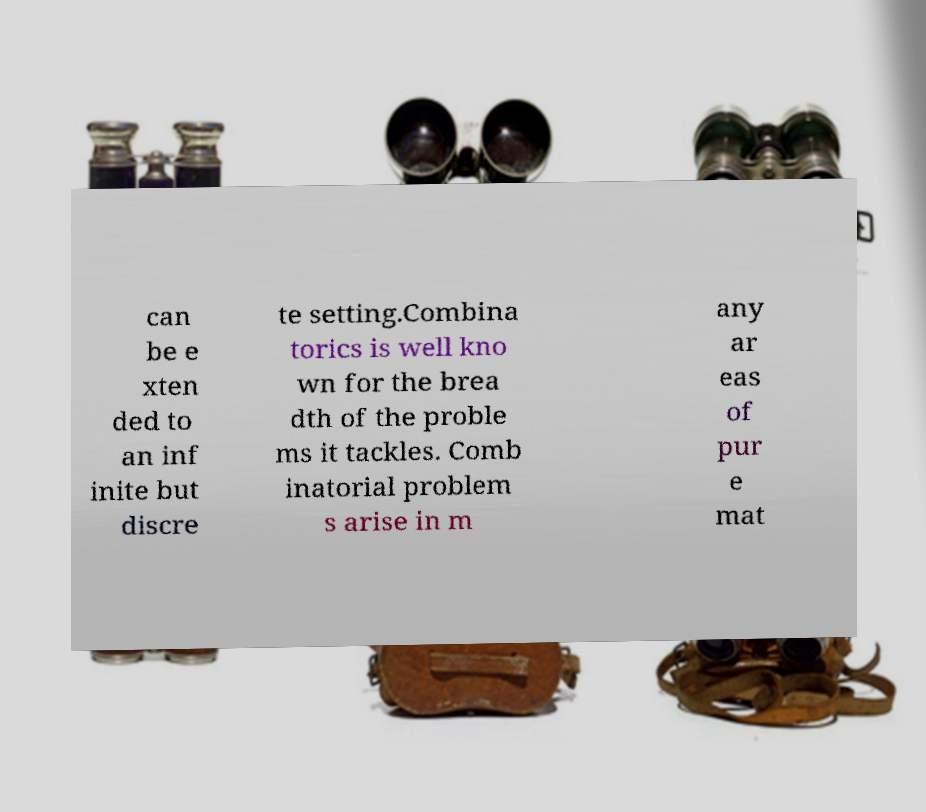Can you read and provide the text displayed in the image?This photo seems to have some interesting text. Can you extract and type it out for me? can be e xten ded to an inf inite but discre te setting.Combina torics is well kno wn for the brea dth of the proble ms it tackles. Comb inatorial problem s arise in m any ar eas of pur e mat 